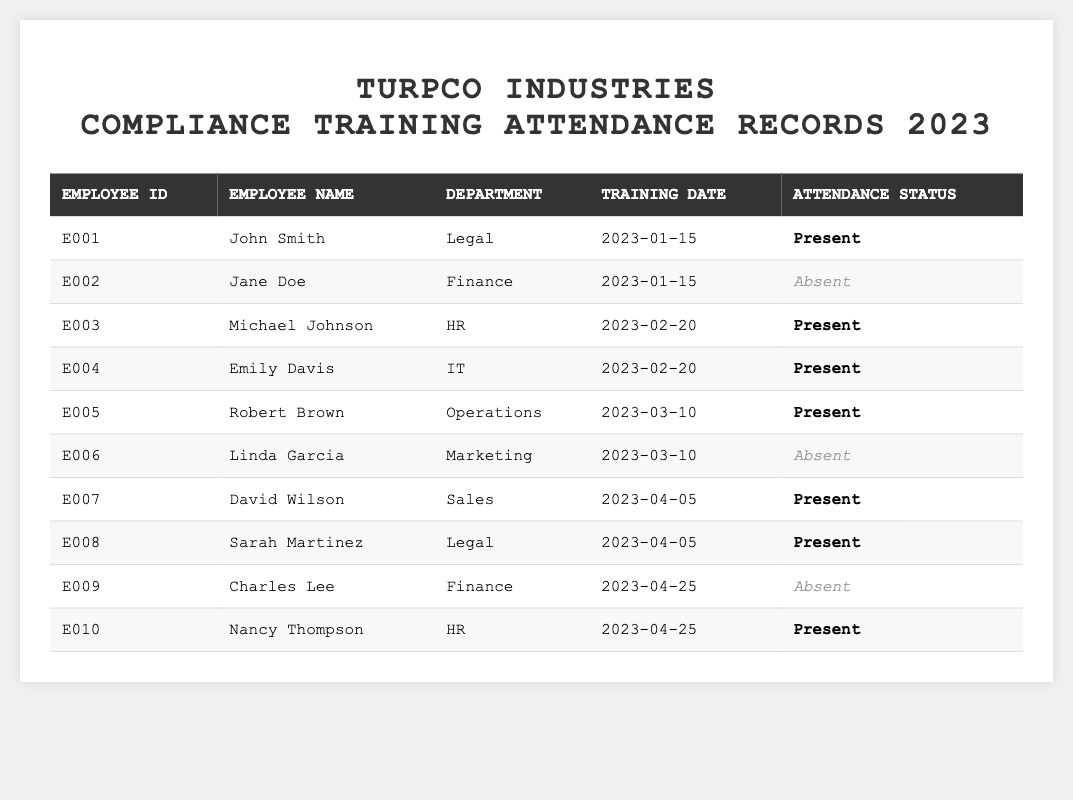What is the attendance status of John Smith? John Smith's entry in the table shows that he attended the training on January 15, 2023, and his attendance status is marked as "Present."
Answer: Present How many employees were absent during the training sessions? By reviewing the table, we find that Jane Doe, Linda Garcia, and Charles Lee were absent, totaling three employees.
Answer: 3 Which department had the highest attendance? The Legal department has two employees present (John Smith and Sarah Martinez) while other departments like Finance and HR had one each present and absent. This indicates that the Legal department had the highest attendance.
Answer: Legal What was the training date for Emily Davis? Referring to the table, Emily Davis's entry indicates that she attended training on February 20, 2023.
Answer: February 20, 2023 Did any employees in the Finance department attend all the training sessions? The table shows that Jane Doe and Charles Lee, the two employees from the Finance department, were both marked as absent for their respective training sessions. Therefore, none attended all sessions.
Answer: No How many employees attended trainings in total up to April 25, 2023? Upon tallying the attendance status from the table, there were 7 instances of "Present," indicating that 7 employees attended.
Answer: 7 What is the average attendance status by department for the Legal department? In the Legal department, both John Smith and Sarah Martinez attended the training session, making the average attendance status 100% since both were present.
Answer: 100% How many training sessions were held in total? Looking through each training date listed in the table, there were training sessions held on January 15, February 20, March 10, April 5, and April 25, resulting in a total of 5 training sessions.
Answer: 5 Which employee had the latest training date, and what was their attendance status? The most recent training date in the table is April 25, 2023, attended by Nancy Thompson, whose attendance status is "Present."
Answer: Nancy Thompson, Present Is there any employee from the IT department who attended training? Checking the table, Emily Davis from the IT department is marked as "Present" for the training session on February 20, 2023, indicating she attended.
Answer: Yes 